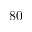<formula> <loc_0><loc_0><loc_500><loc_500>8 0</formula> 